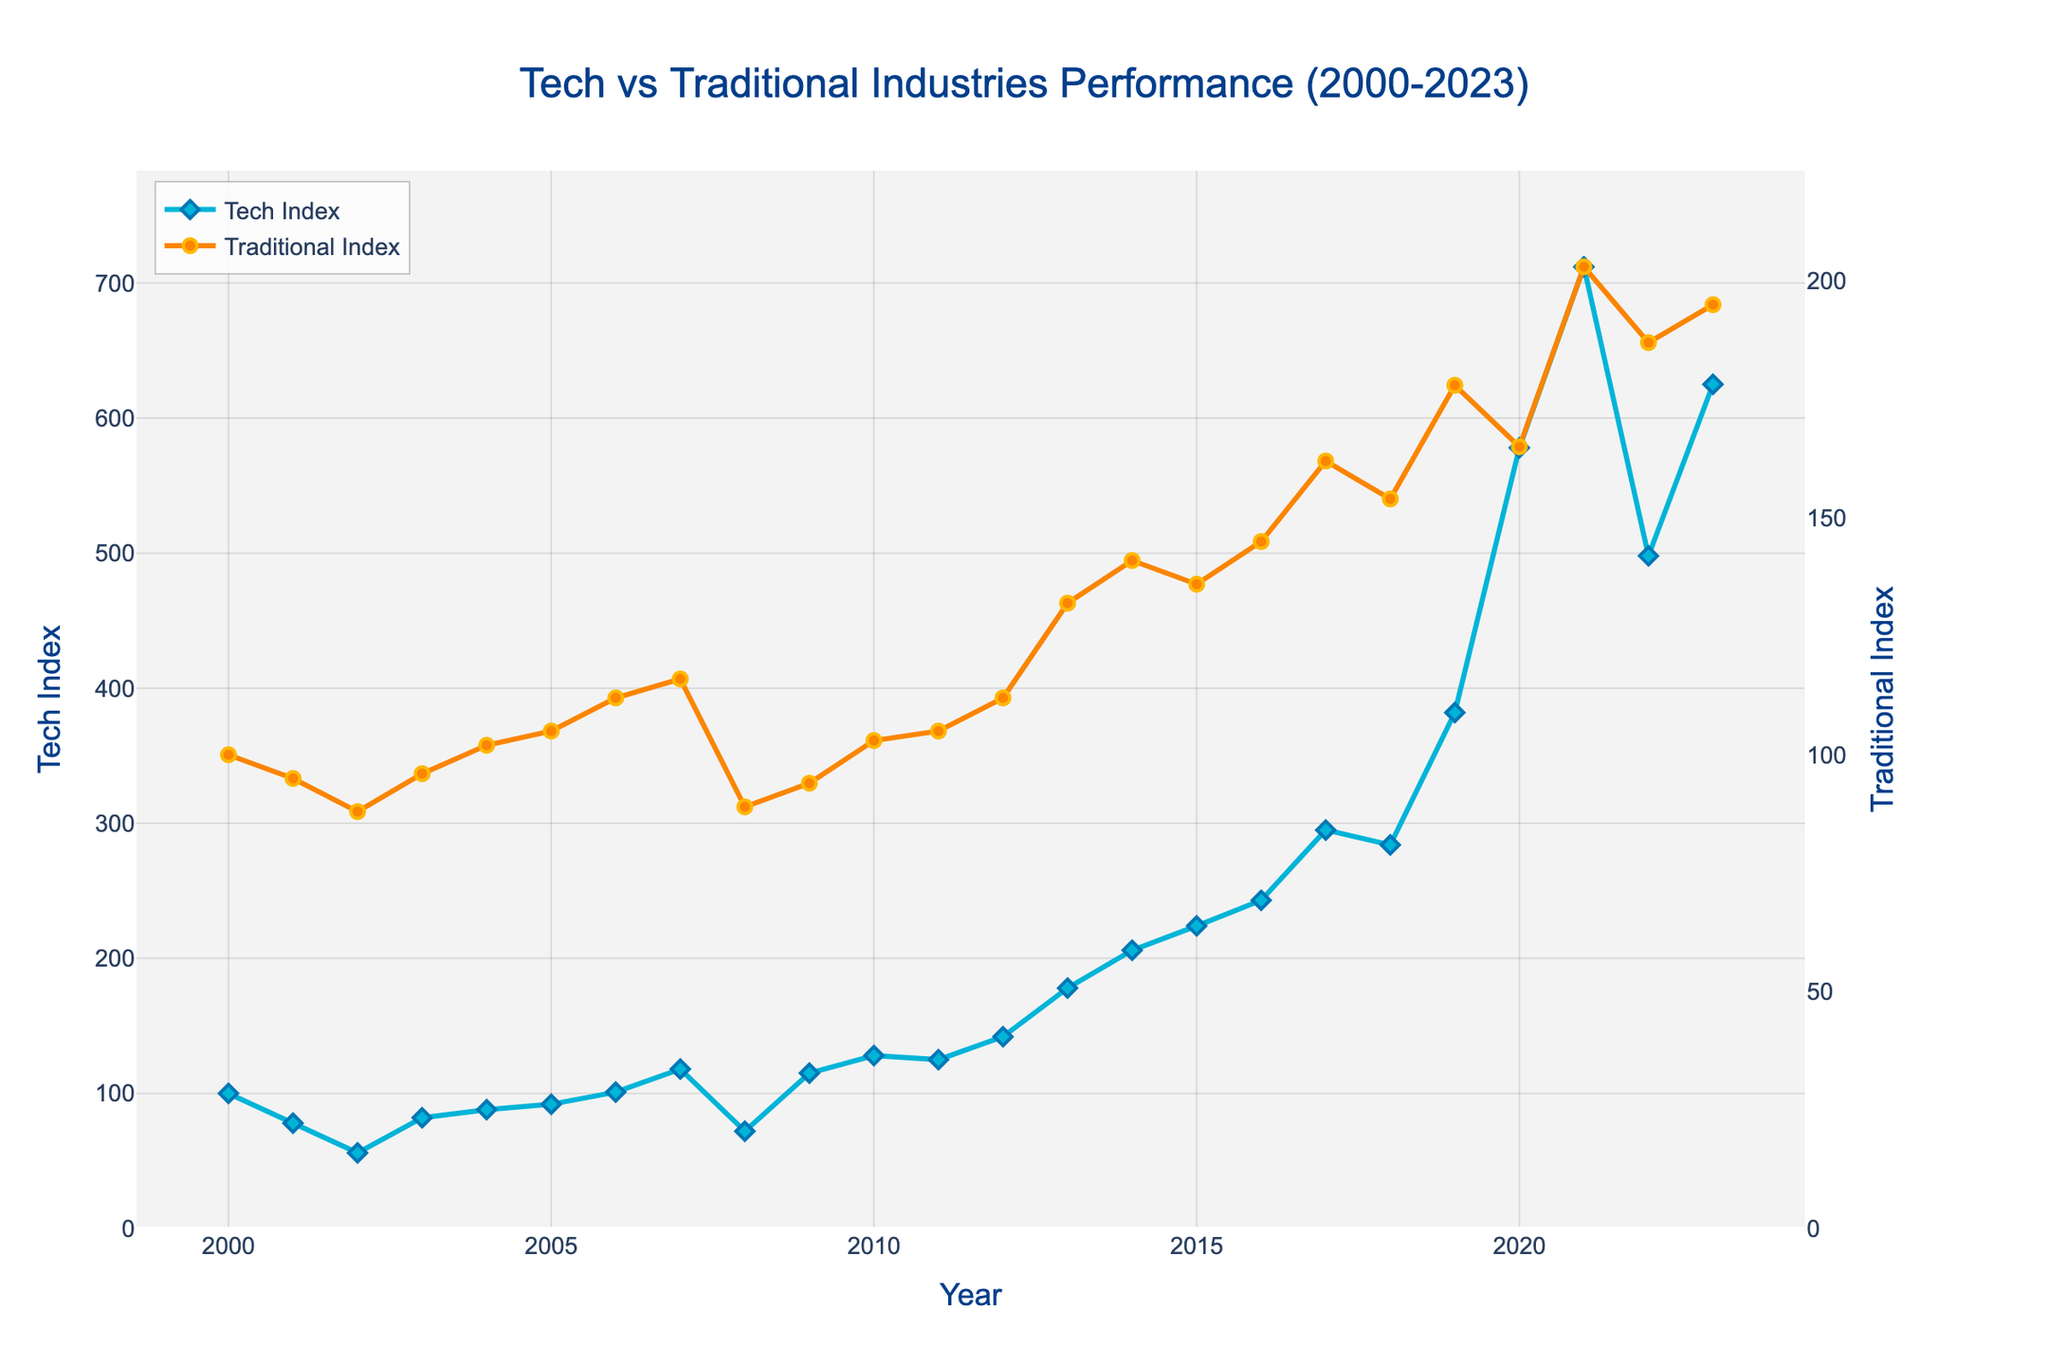What is the general trend of the Tech Index from 2000 to 2023? Observing the line chart, the Tech Index initially decreases until around 2002, followed by a general upward trend with some fluctuations. Significant rises are seen around 2013–2021 with a notable peak in 2021, followed by a dip and another rise up to 2023.
Answer: Increasing trend, especially post-2003 with a peak in 2021 What was the Tech Index value in 2008 compared to its value in 2009? In 2008, the Tech Index value is shown as 72, whereas in 2009 it is significantly higher at 115. This indicates a substantial recovery in the Tech Index during this period.
Answer: 72 in 2008 and 115 in 2009 Which year shows the highest value for the Tech Index and what is that value? From the graph, it is clear that 2021 shows the highest value for the Tech Index at approximately 712. This is the peak point visible in the data.
Answer: 2021, value 712 How do the Traditional and Tech indices compare in 2020? In 2020, the Tech Index is around 578, whereas the Traditional Index is about 165, showing that the Tech Index is significantly higher than the Traditional Index in that year.
Answer: Tech Index: 578, Traditional Index: 165 Between what years did the Tech Index experience the most significant growth? The most significant growth in the Tech Index occurs between 2019 and 2021, where it jumps from about 382 to 712. This leap is the largest visible in the data set.
Answer: 2019 to 2021 Which index had a higher value in 2003? By visually comparing both lines in the chart for the year 2003, the Traditional Index at approximately 96 is higher than the Tech Index at roughly 82.
Answer: Traditional Index What is the difference in values of the Traditional Index between 2000 and 2023? The Traditional Index in 2000 is about 100, while in 2023 it is about 195. The difference is thus 195 - 100 = 95.
Answer: 95 During which period did the Traditional Index show a relatively steady growth? From visually analyzing the chart, the Traditional Index shows steady growth from around 2010 to 2021, with small fluctuations but a clear upward trajectory.
Answer: 2010 to 2021 What are the changes in the Tech Index from 2001 to 2003? From the data, the Tech Index decreases from 78 in 2001 to 56 in 2002, and then increases to 82 in 2003. Hence, it initially decreases by 22 and then increases by 26.
Answer: Decreased by 22, then increased by 26 Which index experienced a greater recovery after the 2008 decline? After the 2008 decline, the Tech Index recovers from 72 to 115 in 2009, a change of 43 points. The Traditional Index moves from 89 to 94 during the same period, a change of 5 points. Thus, the Tech Index experienced a greater recovery.
Answer: Tech Index 